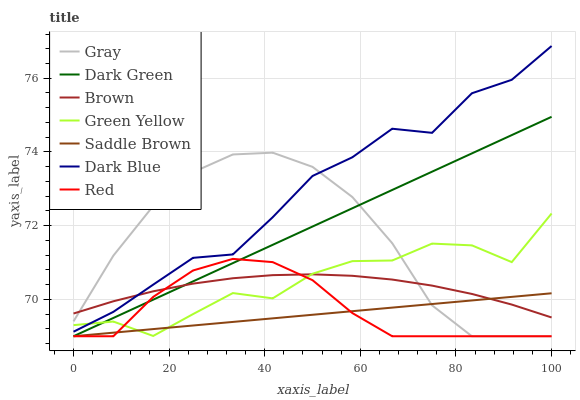Does Saddle Brown have the minimum area under the curve?
Answer yes or no. Yes. Does Dark Blue have the maximum area under the curve?
Answer yes or no. Yes. Does Brown have the minimum area under the curve?
Answer yes or no. No. Does Brown have the maximum area under the curve?
Answer yes or no. No. Is Saddle Brown the smoothest?
Answer yes or no. Yes. Is Green Yellow the roughest?
Answer yes or no. Yes. Is Brown the smoothest?
Answer yes or no. No. Is Brown the roughest?
Answer yes or no. No. Does Dark Blue have the lowest value?
Answer yes or no. No. Does Brown have the highest value?
Answer yes or no. No. Is Dark Green less than Dark Blue?
Answer yes or no. Yes. Is Dark Blue greater than Saddle Brown?
Answer yes or no. Yes. Does Dark Green intersect Dark Blue?
Answer yes or no. No. 